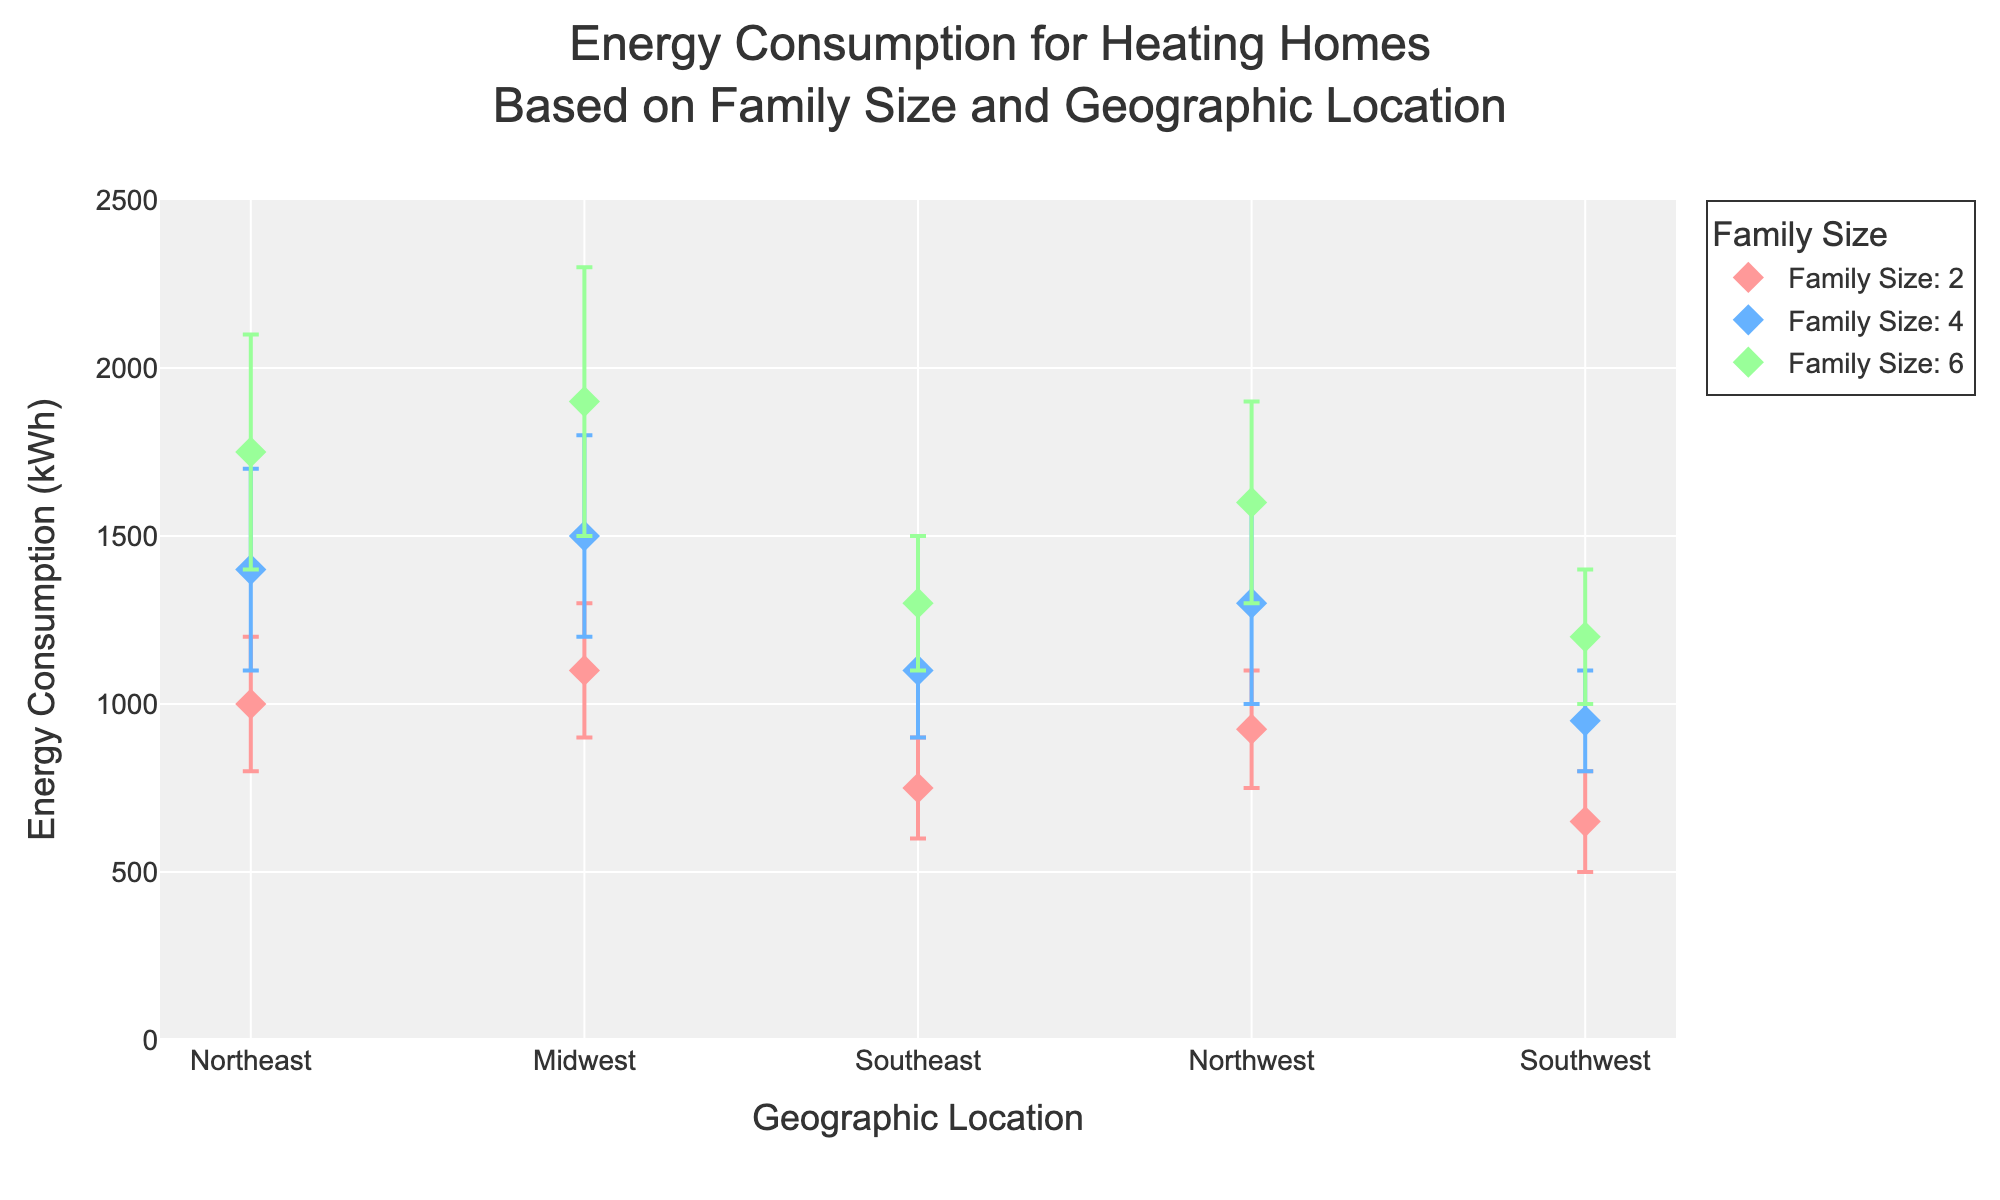What's the title of the plot? The title of the plot is written at the top of the figure. It provides a summary of what the plot is about. The title in this case is "Energy Consumption for Heating Homes Based on Family Size and Geographic Location".
Answer: Energy Consumption for Heating Homes Based on Family Size and Geographic Location What geographic location has the lowest maximum energy consumption for a family size of 4? The maximum energy consumption values for a family size of 4 can be compared across all geographic locations. By comparing, the Southwest has the lowest maximum energy consumption at 1100 kWh.
Answer: Southwest How does the average energy consumption for a family of 6 in the Northeast compare to the Midwest? The average energy consumption for a family of 6 in the Northeast is (1400+2100)/2 = 1750 kWh. In the Midwest, it is (1500+2300)/2 = 1900 kWh. By comparison, the Midwest has a higher average energy consumption.
Answer: Midwest is higher What's the average energy consumption for a family size of 2 in the Southeast? The average energy consumption is calculated as the midpoint between the minimum and maximum energy consumption. In the Southeast, it is (600+900)/2 = 750 kWh.
Answer: 750 kWh Which family size has the highest maximum energy consumption in the Northwest? By examining the maximum energy consumption values for the Northwest across different family sizes, the family size of 6 has the highest maximum energy consumption at 1900 kWh.
Answer: 6 For the Midwest, what is the range of energy consumption for a family size of 4? The range is determined by subtracting the minimum energy consumption from the maximum energy consumption. For the Midwest, the range is 1800 kWh - 1200 kWh = 600 kWh.
Answer: 600 kWh Which location has the most consistent energy consumption for family size 2? Consistency can be measured by the smallest range (difference between min and max). The Southwest has a range of 800-500=300 kWh, which is the smallest among all locations for family size 2.
Answer: Southwest How does the energy consumption range for a family of 4 in the Northeast compare to that of a family of 4 in the Southeast? For the Northeast, the range is 1700 kWh - 1100 kWh = 600 kWh. For the Southeast, the range is 1300 kWh - 900 kWh = 400 kWh. Therefore, the range is larger in the Northeast.
Answer: Northeast is larger Do larger family sizes generally require more energy for heating in the Northwest? By observing the energy consumption values for different family sizes in the Northwest, it can be seen that energy consumption increases with family size. Family size 2 ranges from 750 to 1100 kWh, size 4 ranges from 1000 to 1600 kWh, and size 6 ranges from 1300 to 1900 kWh.
Answer: Yes 